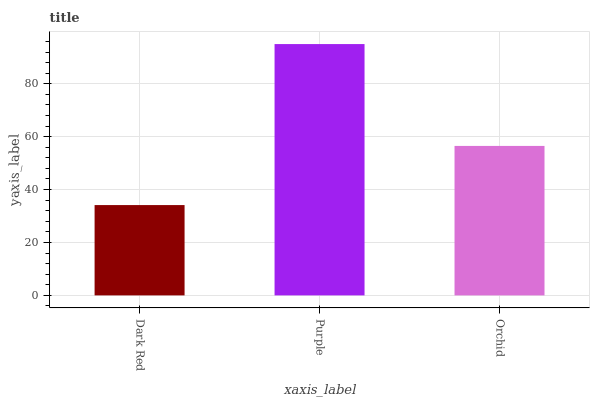Is Dark Red the minimum?
Answer yes or no. Yes. Is Purple the maximum?
Answer yes or no. Yes. Is Orchid the minimum?
Answer yes or no. No. Is Orchid the maximum?
Answer yes or no. No. Is Purple greater than Orchid?
Answer yes or no. Yes. Is Orchid less than Purple?
Answer yes or no. Yes. Is Orchid greater than Purple?
Answer yes or no. No. Is Purple less than Orchid?
Answer yes or no. No. Is Orchid the high median?
Answer yes or no. Yes. Is Orchid the low median?
Answer yes or no. Yes. Is Dark Red the high median?
Answer yes or no. No. Is Dark Red the low median?
Answer yes or no. No. 